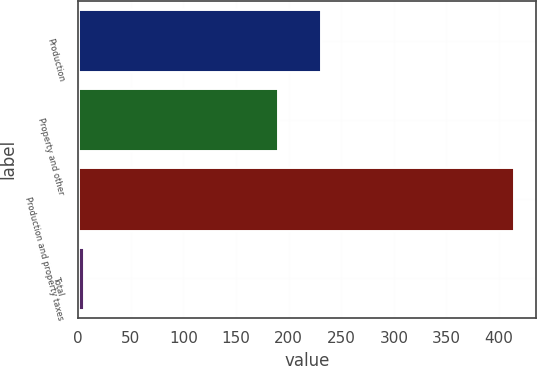Convert chart to OTSL. <chart><loc_0><loc_0><loc_500><loc_500><bar_chart><fcel>Production<fcel>Property and other<fcel>Production and property taxes<fcel>Total<nl><fcel>230.82<fcel>190<fcel>414<fcel>5.78<nl></chart> 